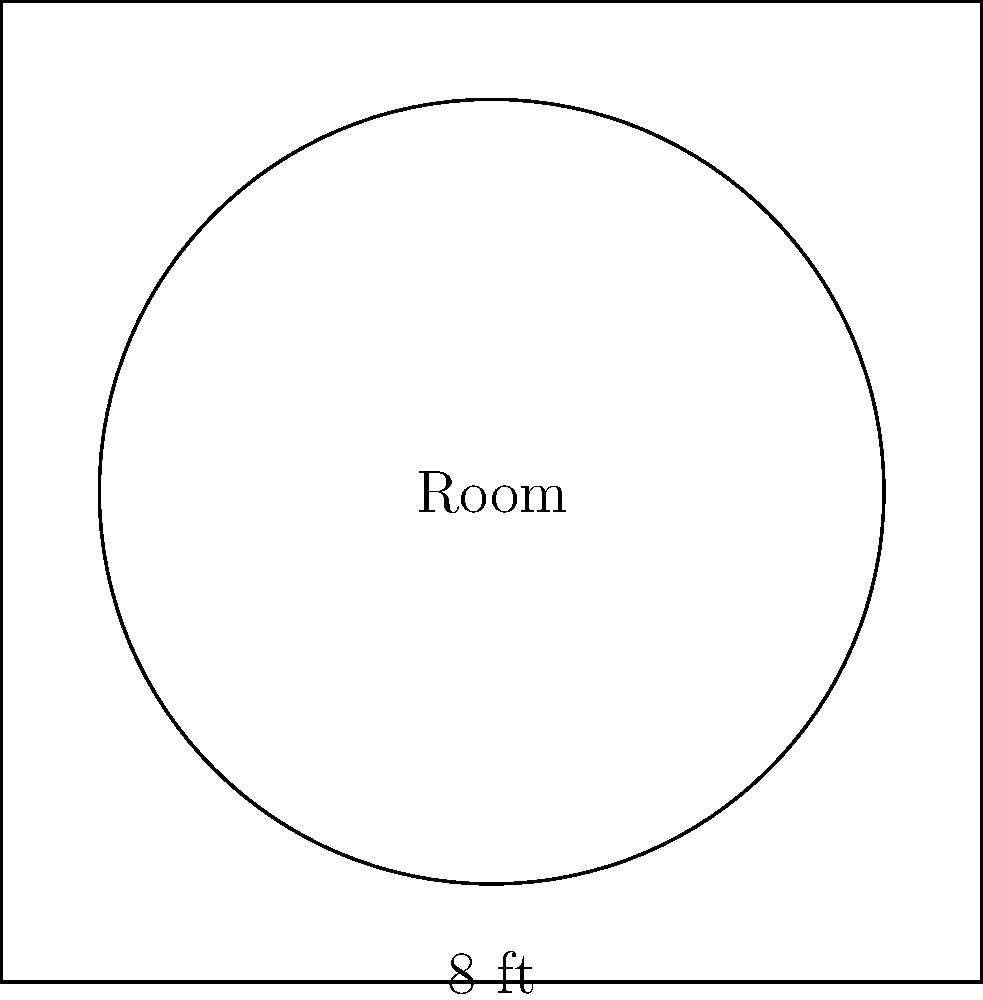A patient's room has a circular area where a new rug needs to be placed. The diameter of this circular area is 8 feet. What is the area of the circular rug needed to fit perfectly in this space? To find the area of the circular rug, we need to follow these steps:

1. Identify the given information:
   - The diameter of the circular area is 8 feet

2. Calculate the radius:
   - Radius = Diameter ÷ 2
   - Radius = 8 ÷ 2 = 4 feet

3. Use the formula for the area of a circle:
   - Area = $\pi r^2$, where $r$ is the radius

4. Substitute the radius value into the formula:
   - Area = $\pi \times 4^2$
   - Area = $\pi \times 16$

5. Calculate the final result:
   - Area ≈ 3.14159 × 16
   - Area ≈ 50.27 square feet

Therefore, the area of the circular rug needed is approximately 50.27 square feet.
Answer: $50.27 \text{ ft}^2$ 